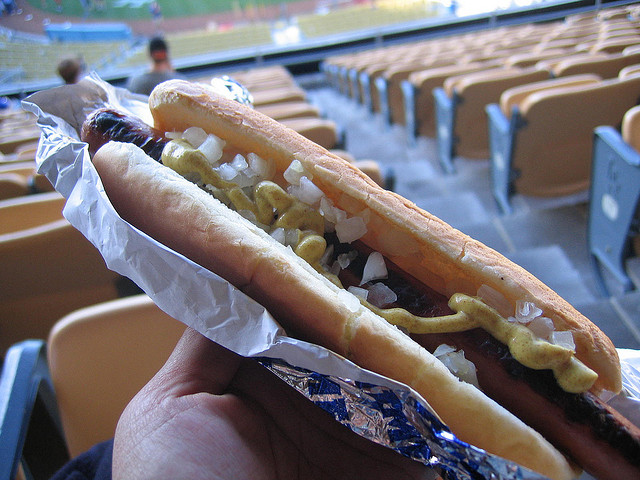<image>How much does this hotdog cost? It is unknown how much the hotdog costs. How much does this hotdog cost? I don't know how much this hotdog costs. It can be seen for 2 dollars, 4.99, 1.50, 5.00, 2.50 or 5 dollars. 